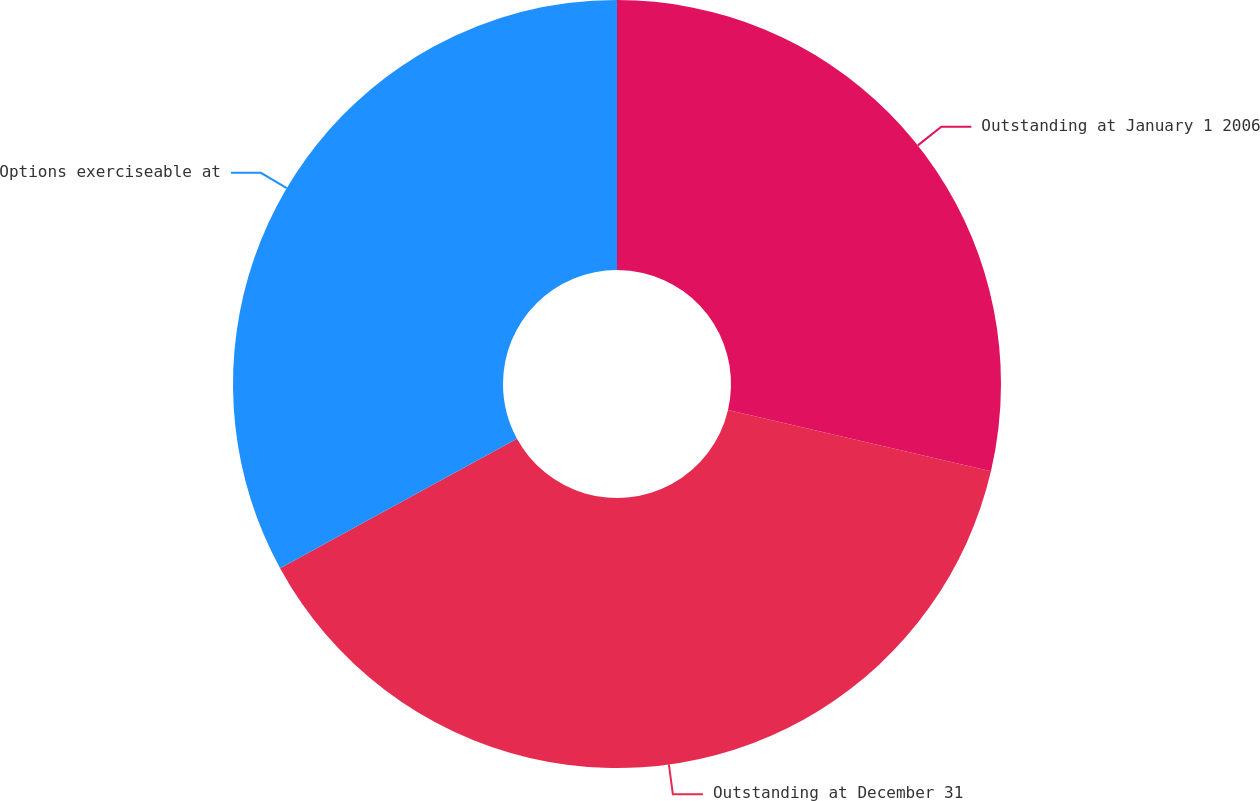Convert chart. <chart><loc_0><loc_0><loc_500><loc_500><pie_chart><fcel>Outstanding at January 1 2006<fcel>Outstanding at December 31<fcel>Options exerciseable at<nl><fcel>28.65%<fcel>38.38%<fcel>32.96%<nl></chart> 